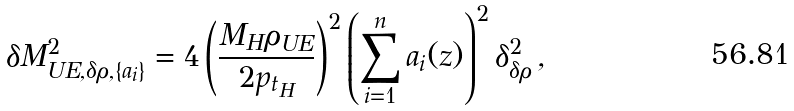Convert formula to latex. <formula><loc_0><loc_0><loc_500><loc_500>\delta M _ { U E , \delta \rho , \{ a _ { i } \} } ^ { 2 } = 4 \left ( \frac { M _ { H } \rho _ { U E } } { 2 p _ { t _ { H } } } \right ) ^ { 2 } \left ( \sum _ { i = 1 } ^ { n } a _ { i } ( z ) \right ) ^ { 2 } \delta _ { \delta \rho } ^ { 2 } \, ,</formula> 